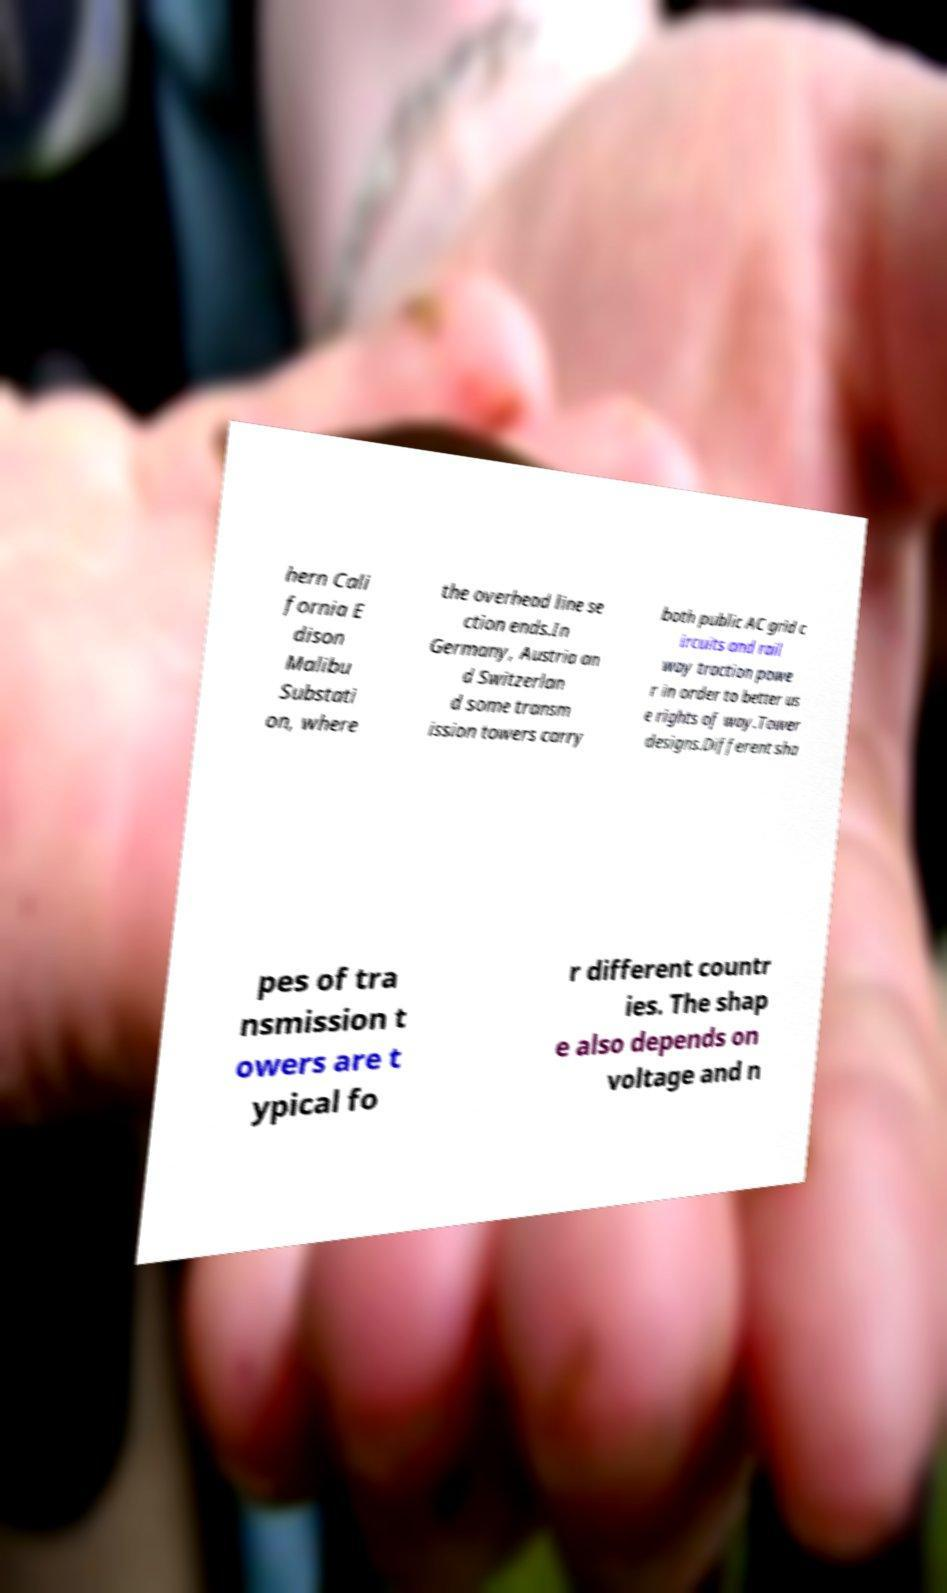Can you accurately transcribe the text from the provided image for me? hern Cali fornia E dison Malibu Substati on, where the overhead line se ction ends.In Germany, Austria an d Switzerlan d some transm ission towers carry both public AC grid c ircuits and rail way traction powe r in order to better us e rights of way.Tower designs.Different sha pes of tra nsmission t owers are t ypical fo r different countr ies. The shap e also depends on voltage and n 